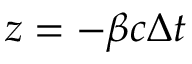<formula> <loc_0><loc_0><loc_500><loc_500>z = - \beta c \Delta t</formula> 